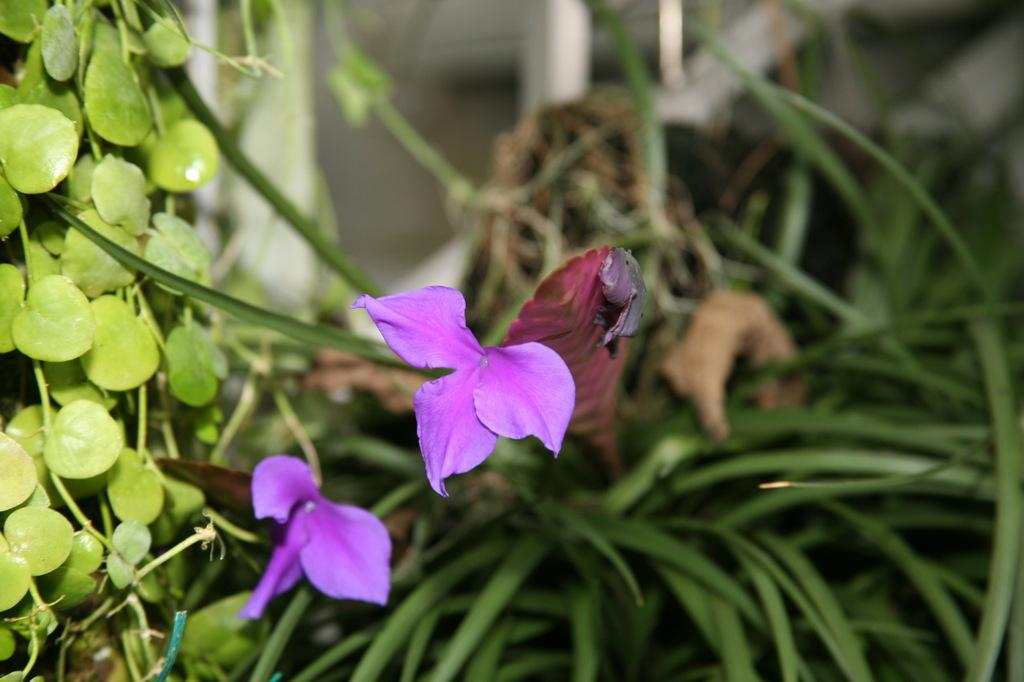What type of flora can be seen in the image? There are flowers, plants, and trees with leaves in the image. What color are the flowers in the image? The flowers in the image are violet in color. How many frogs are sitting on the canvas in the image? There is no canvas or frogs present in the image. 